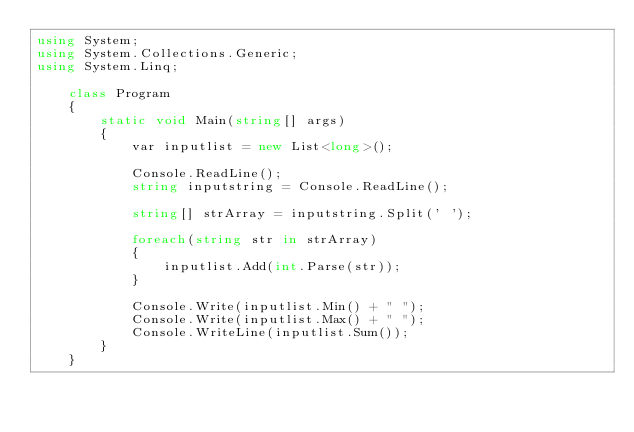<code> <loc_0><loc_0><loc_500><loc_500><_C#_>using System;
using System.Collections.Generic;
using System.Linq;

    class Program
    {
        static void Main(string[] args)
        {
            var inputlist = new List<long>();

            Console.ReadLine();
            string inputstring = Console.ReadLine();

            string[] strArray = inputstring.Split(' ');

            foreach(string str in strArray)
            {
                inputlist.Add(int.Parse(str));
            }

            Console.Write(inputlist.Min() + " ");
            Console.Write(inputlist.Max() + " ");
            Console.WriteLine(inputlist.Sum());
        }
    }
</code> 